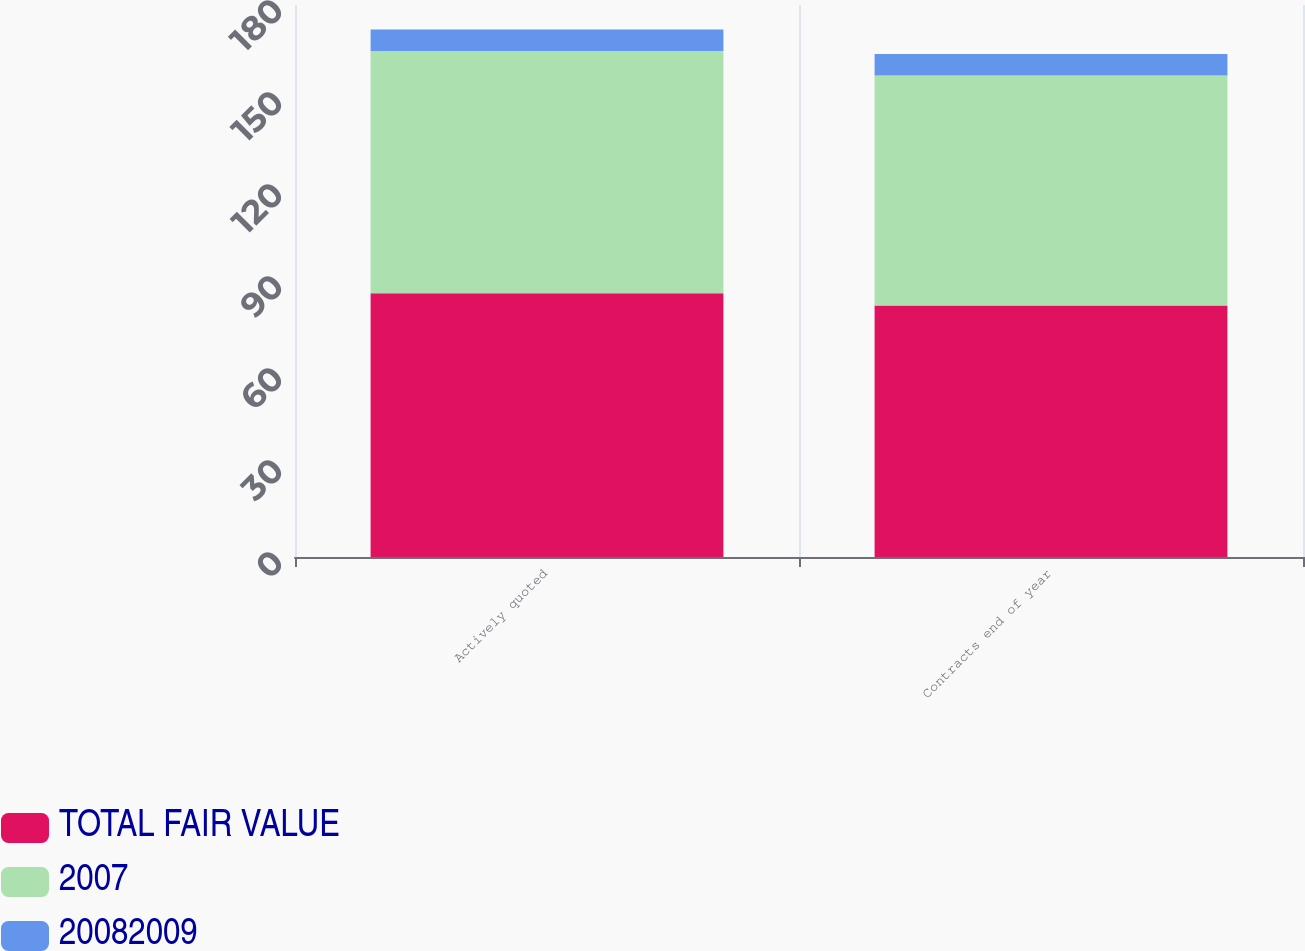Convert chart. <chart><loc_0><loc_0><loc_500><loc_500><stacked_bar_chart><ecel><fcel>Actively quoted<fcel>Contracts end of year<nl><fcel>TOTAL FAIR VALUE<fcel>86<fcel>82<nl><fcel>2007<fcel>79<fcel>75<nl><fcel>20082009<fcel>7<fcel>7<nl></chart> 